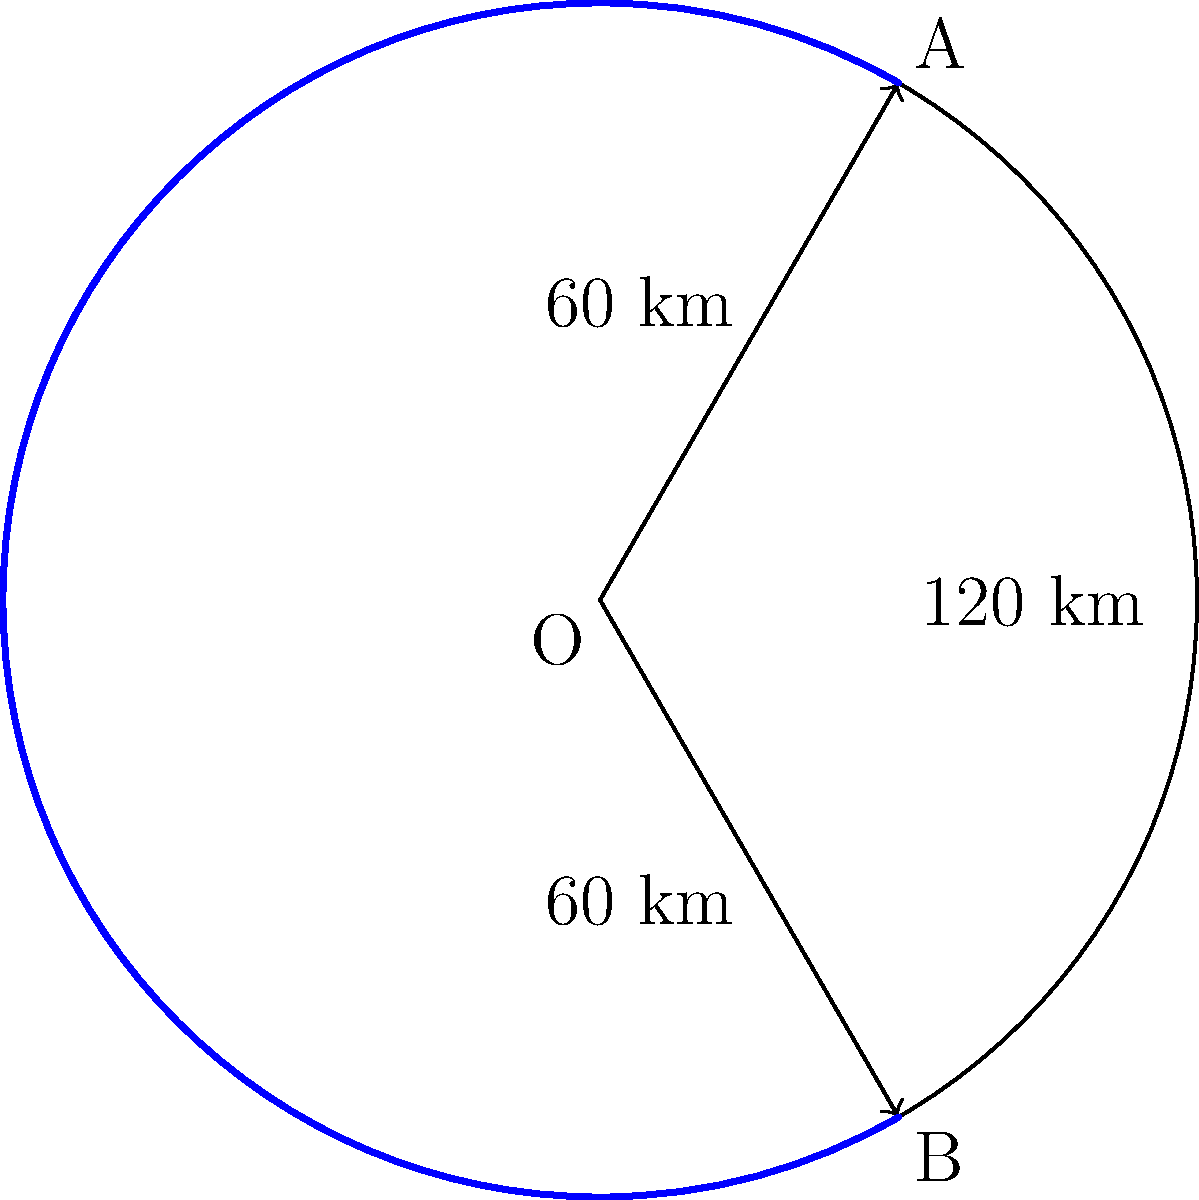As a transportation coordinator, you're planning a circular bus route in a city. The route starts at point A, goes through the city center O, and ends at point B. If the distance from O to A and O to B is 60 km each, and the arc length of the route from A to B is 120 km, what is the central angle (in degrees) of the sector AOB? Let's approach this step-by-step:

1) In a circle, the central angle $\theta$ (in radians) is related to the arc length $s$ and radius $r$ by the formula:

   $$\theta = \frac{s}{r}$$

2) We're given that the arc length (s) is 120 km and the radius (r) is 60 km.

3) Substituting these values:

   $$\theta = \frac{120 \text{ km}}{60 \text{ km}} = 2 \text{ radians}$$

4) Now we need to convert this to degrees. The conversion factor is:

   $$1 \text{ radian} = \frac{180}{\pi} \text{ degrees}$$

5) So, our angle in degrees is:

   $$\theta_{\text{degrees}} = 2 \times \frac{180}{\pi} = \frac{360}{\pi} \approx 114.59 \text{ degrees}$$

6) Rounding to the nearest degree:

   $$\theta_{\text{degrees}} \approx 115 \text{ degrees}$$

Thus, the central angle of the sector AOB is approximately 115 degrees.
Answer: 115° 